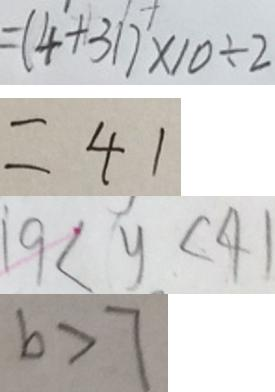<formula> <loc_0><loc_0><loc_500><loc_500>= ( 4 + 3 1 ) \times 1 0 \div 2 
 = 4 1 
 1 9 < y < 4 1 
 b > 7</formula> 